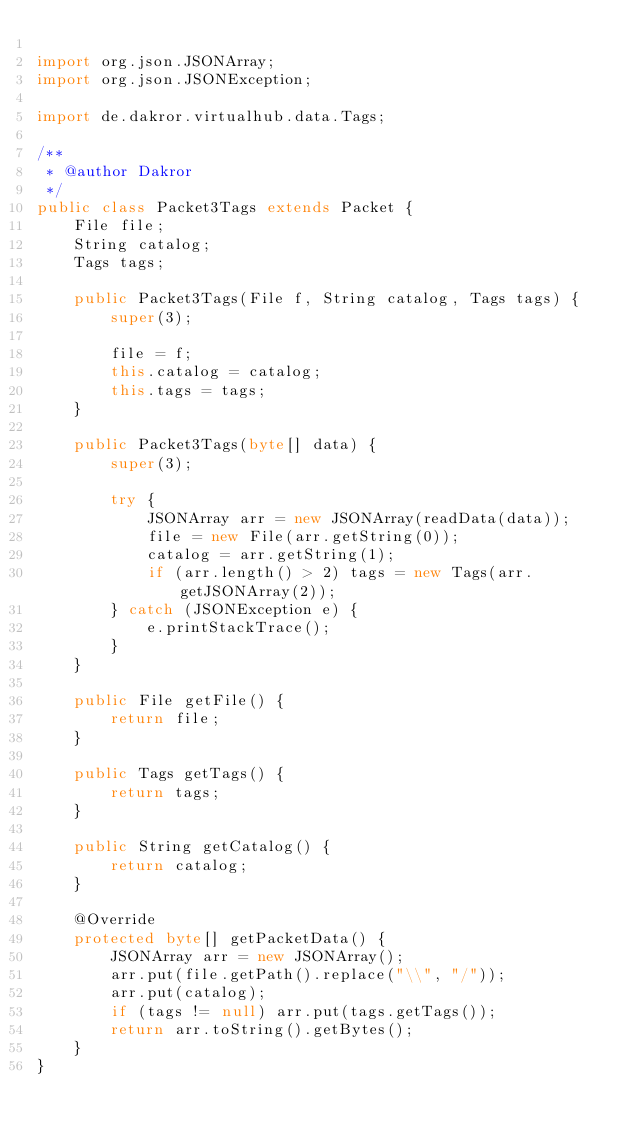<code> <loc_0><loc_0><loc_500><loc_500><_Java_>
import org.json.JSONArray;
import org.json.JSONException;

import de.dakror.virtualhub.data.Tags;

/**
 * @author Dakror
 */
public class Packet3Tags extends Packet {
	File file;
	String catalog;
	Tags tags;
	
	public Packet3Tags(File f, String catalog, Tags tags) {
		super(3);
		
		file = f;
		this.catalog = catalog;
		this.tags = tags;
	}
	
	public Packet3Tags(byte[] data) {
		super(3);
		
		try {
			JSONArray arr = new JSONArray(readData(data));
			file = new File(arr.getString(0));
			catalog = arr.getString(1);
			if (arr.length() > 2) tags = new Tags(arr.getJSONArray(2));
		} catch (JSONException e) {
			e.printStackTrace();
		}
	}
	
	public File getFile() {
		return file;
	}
	
	public Tags getTags() {
		return tags;
	}
	
	public String getCatalog() {
		return catalog;
	}
	
	@Override
	protected byte[] getPacketData() {
		JSONArray arr = new JSONArray();
		arr.put(file.getPath().replace("\\", "/"));
		arr.put(catalog);
		if (tags != null) arr.put(tags.getTags());
		return arr.toString().getBytes();
	}
}
</code> 